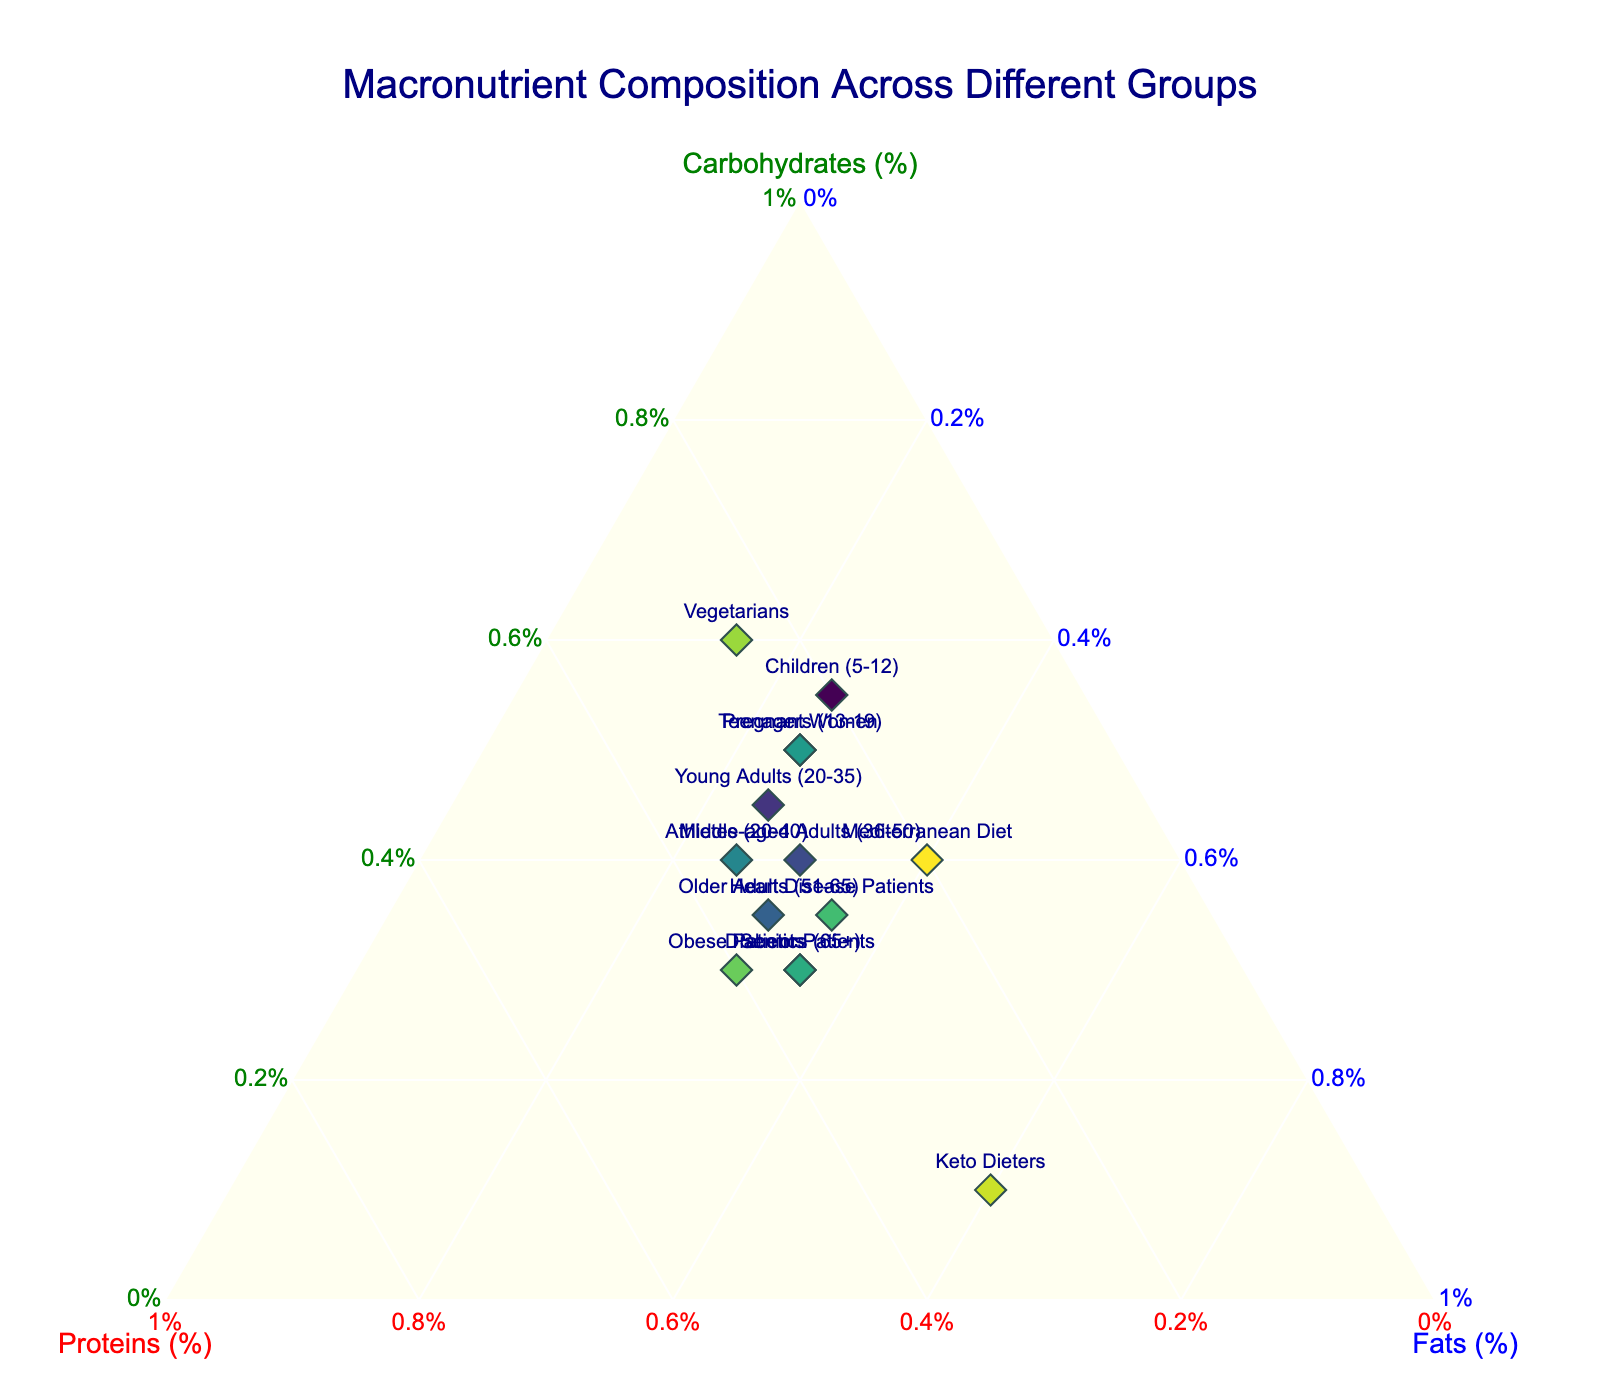Which age group has the highest percentage of carbohydrates in their diet? Observe the data points that are located closest to the Carbohydrates axis (top corner). The group "Vegetarians" is closest to this axis.
Answer: Vegetarians Which group has an equal percentage of proteins and fats? Look for points where the b and c axis values are equal. "Teenagers (13-19)", "Pregnant Women", and "Young Adults (20-35)" have identical percentages of proteins and fats.
Answer: Teenagers (13-19), Pregnant Women, Young Adults (20-35) What is the average percentage of proteins for "Young Adults (20-35)" and "Middle-aged Adults (36-50)"? Combine the protein percentages of Young Adults (30) and Middle-aged Adults (30), then divide by 2 for the average.
Answer: 30 Is the percentage of fats for "Keto Dieters" greater than that for "Seniors (65+)"? Compare the proximity to the Fats axis (right corner) for "Keto Dieters" and "Seniors (65+)". "Keto Dieters" has a higher percentage.
Answer: Yes Which group lies closest to the center of the ternary plot? Identify the data point that is centrally located. "Mediterranean Diet" appears closest to the plot center.
Answer: Mediterranean Diet What is the sum of the percentages of carbohydrates and proteins in "Obese Patients"? Add the carbohydrates (30) plus proteins (40) for "Obese Patients".
Answer: 70 Compare the protein intake between "Children (5-12)" and "Older Adults (51-65)"; which group has a higher protein percentage? Check the values on the proteins axis for both groups. "Older Adults (51-65)" have a higher protein percentage (35%) compared to "Children (5-12)" (20%).
Answer: Older Adults (51-65) Which group has the lowest percentage of carbohydrates in their diet? Locate the point nearest to the Fats/Proteins baseline (bottom right). "Keto Dieters" has the lowest percentage of carbohydrates.
Answer: Keto Dieters How does the carbohydrate intake for "Heart Disease Patients" compare to "Middle-aged Adults (36-50)"? Compare the carbohydrate percentages for both groups. "Heart Disease Patients" have 35%, while "Middle-aged Adults" have 40%.
Answer: Heart Disease Patients have lower carbohydrates 